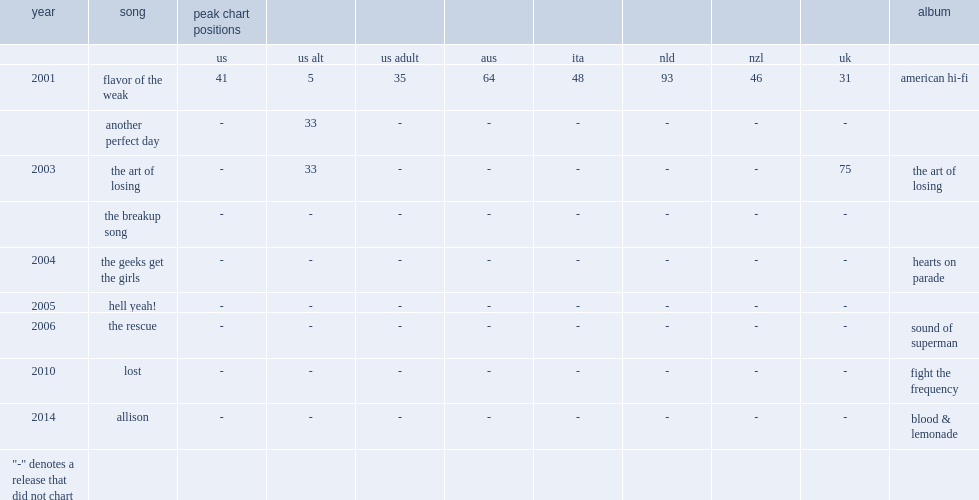Which album followed in 2003 with the singles "the art of losing" and "the breakup song"? The art of losing. 